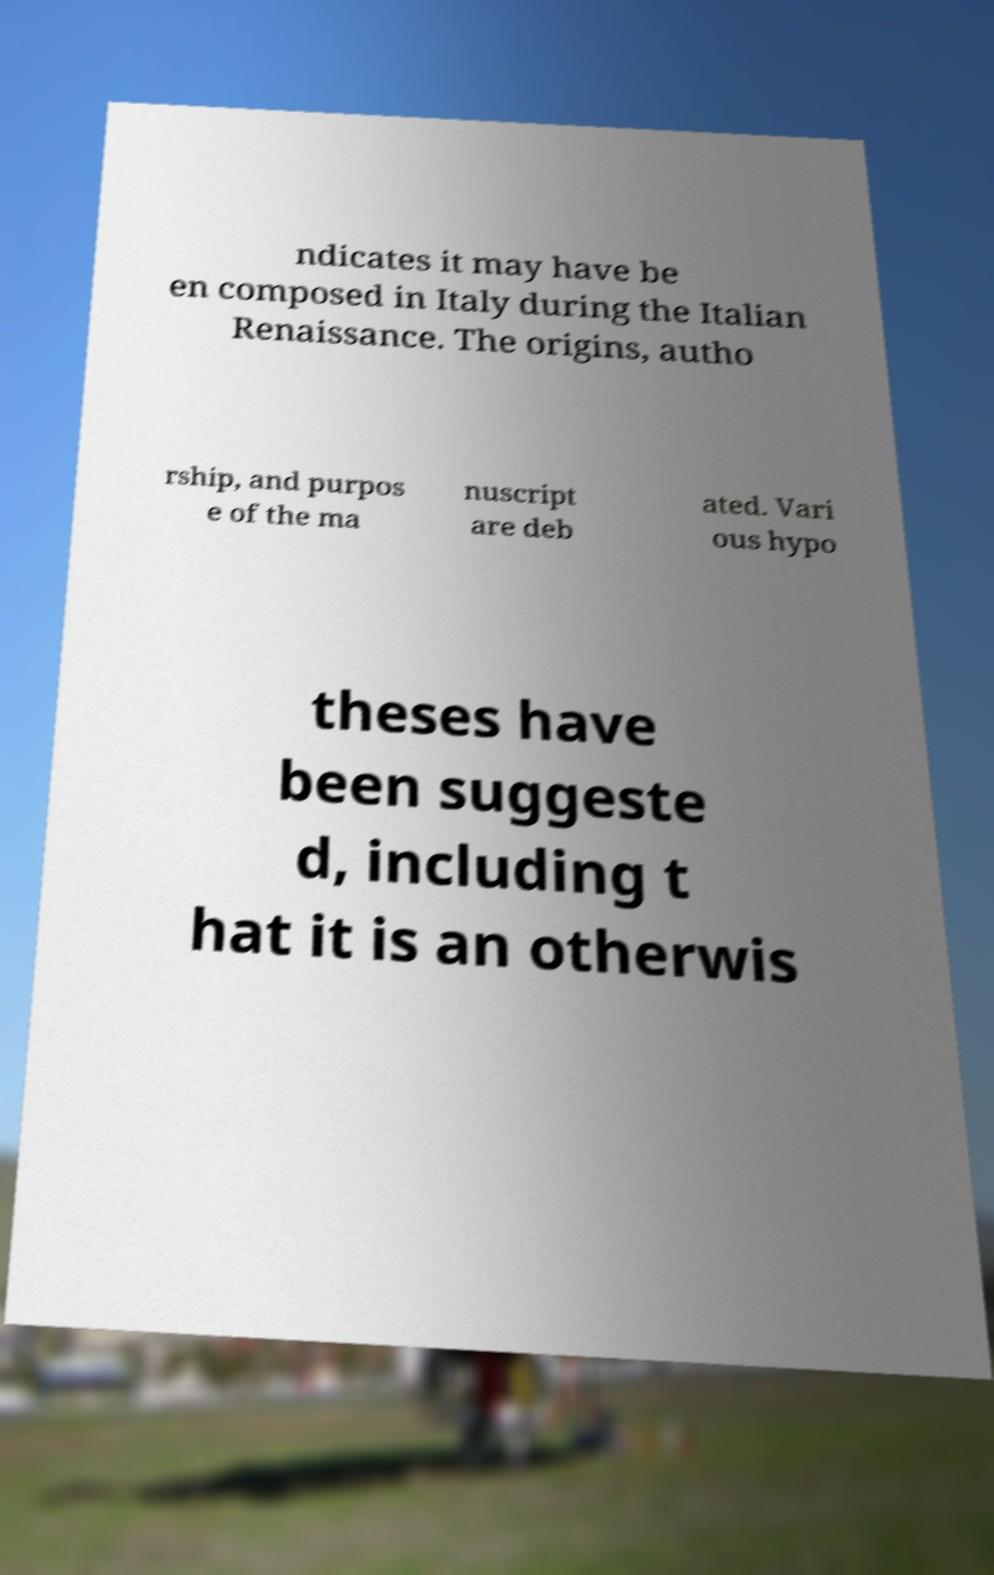For documentation purposes, I need the text within this image transcribed. Could you provide that? ndicates it may have be en composed in Italy during the Italian Renaissance. The origins, autho rship, and purpos e of the ma nuscript are deb ated. Vari ous hypo theses have been suggeste d, including t hat it is an otherwis 